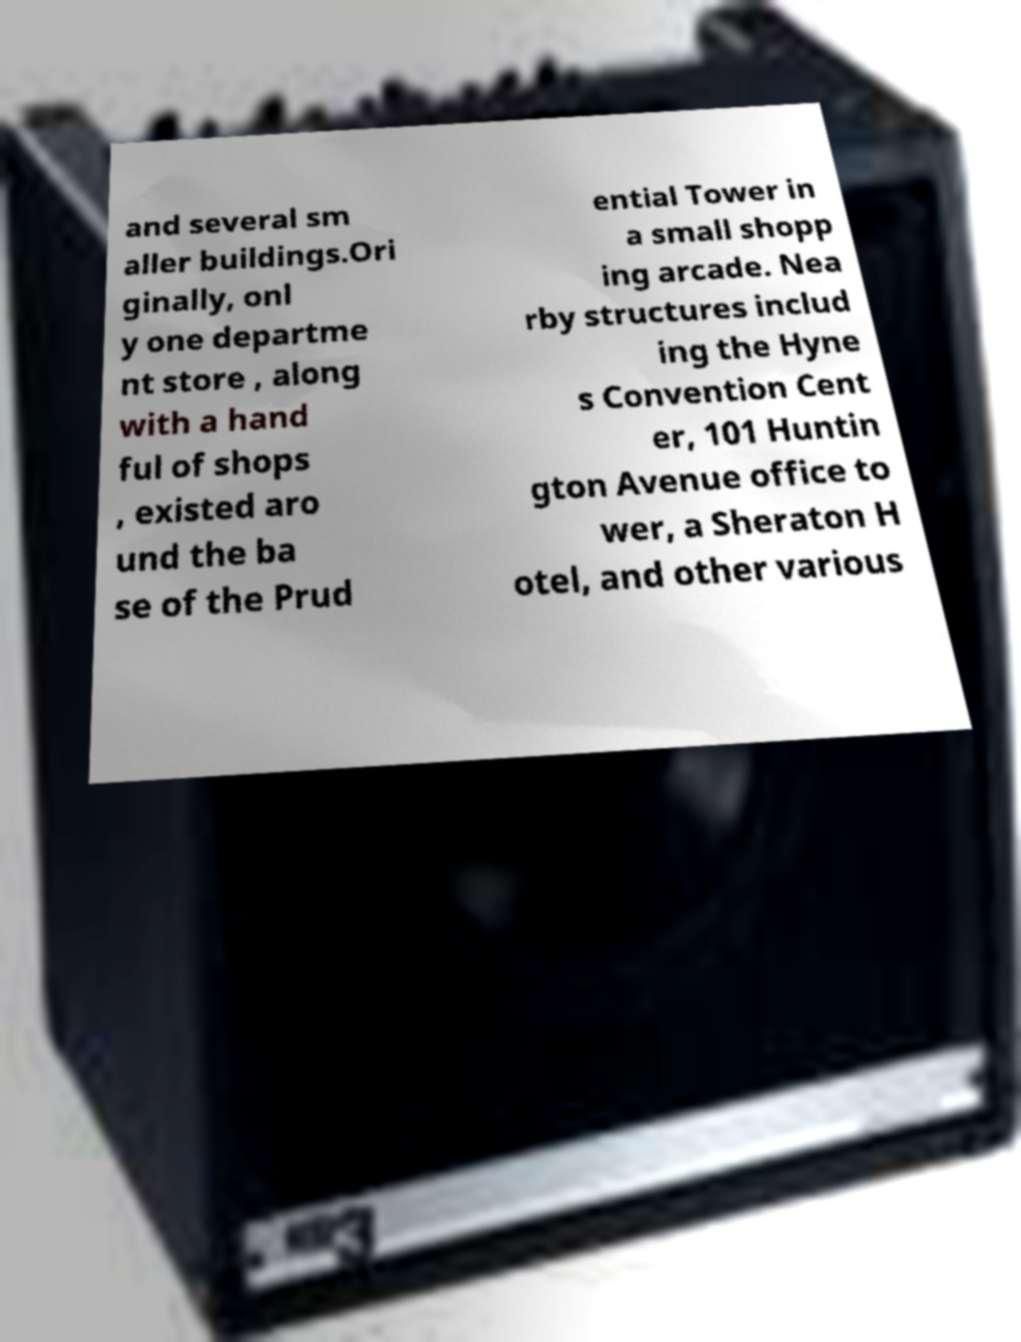Could you extract and type out the text from this image? and several sm aller buildings.Ori ginally, onl y one departme nt store , along with a hand ful of shops , existed aro und the ba se of the Prud ential Tower in a small shopp ing arcade. Nea rby structures includ ing the Hyne s Convention Cent er, 101 Huntin gton Avenue office to wer, a Sheraton H otel, and other various 